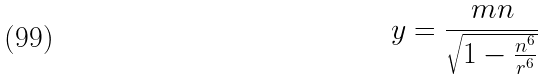<formula> <loc_0><loc_0><loc_500><loc_500>y = \frac { m n } { \sqrt { 1 - \frac { n ^ { 6 } } { r ^ { 6 } } } }</formula> 